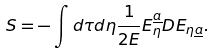Convert formula to latex. <formula><loc_0><loc_0><loc_500><loc_500>S = - \int d \tau d \eta \frac { 1 } { 2 E } E _ { \eta } ^ { \underline { a } } D E _ { \eta \underline { a } } .</formula> 